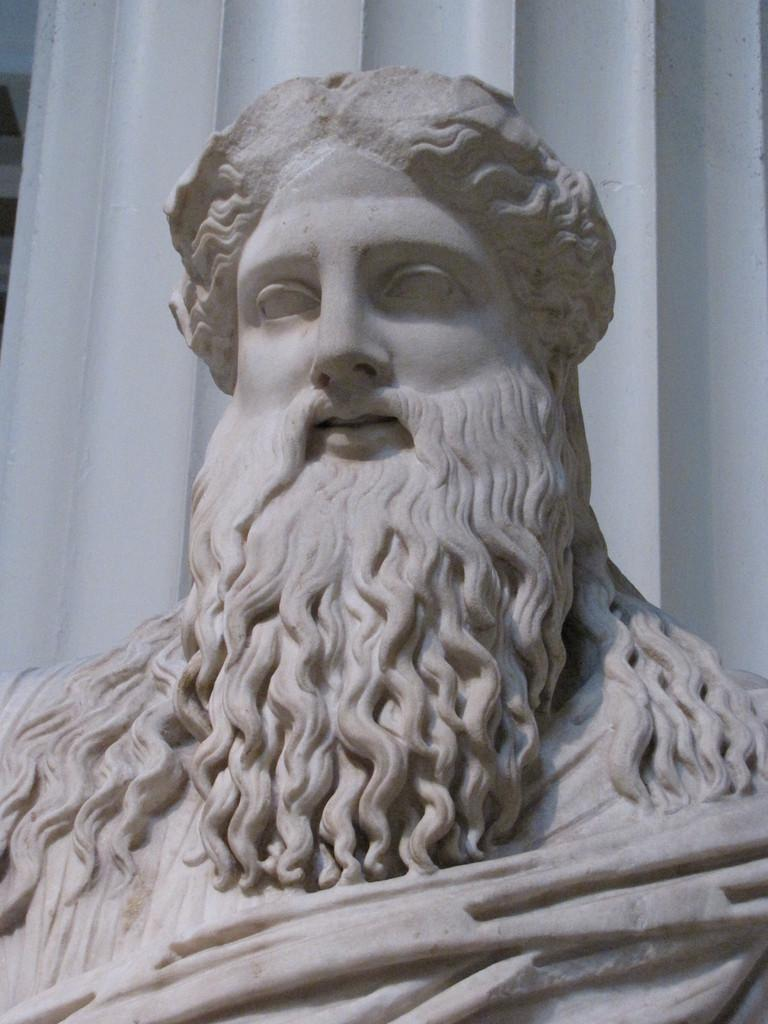What is the main subject of the image? There is a statue of a man in the image. What color is the statue? The statue is in white color. What is visible behind the statue? There is a curtain behind the statue. How many veins can be seen on the statue's arm in the image? There are no veins visible on the statue's arm in the image, as it is a statue made of a material that does not have veins. 